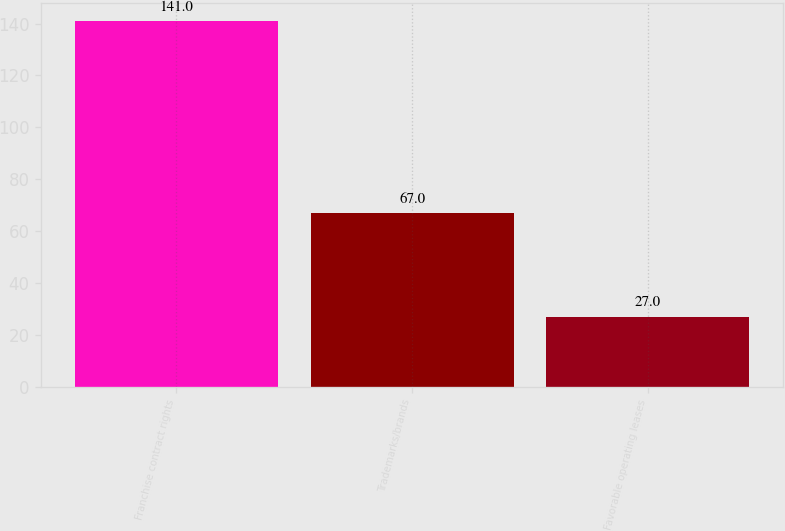Convert chart. <chart><loc_0><loc_0><loc_500><loc_500><bar_chart><fcel>Franchise contract rights<fcel>Trademarks/brands<fcel>Favorable operating leases<nl><fcel>141<fcel>67<fcel>27<nl></chart> 